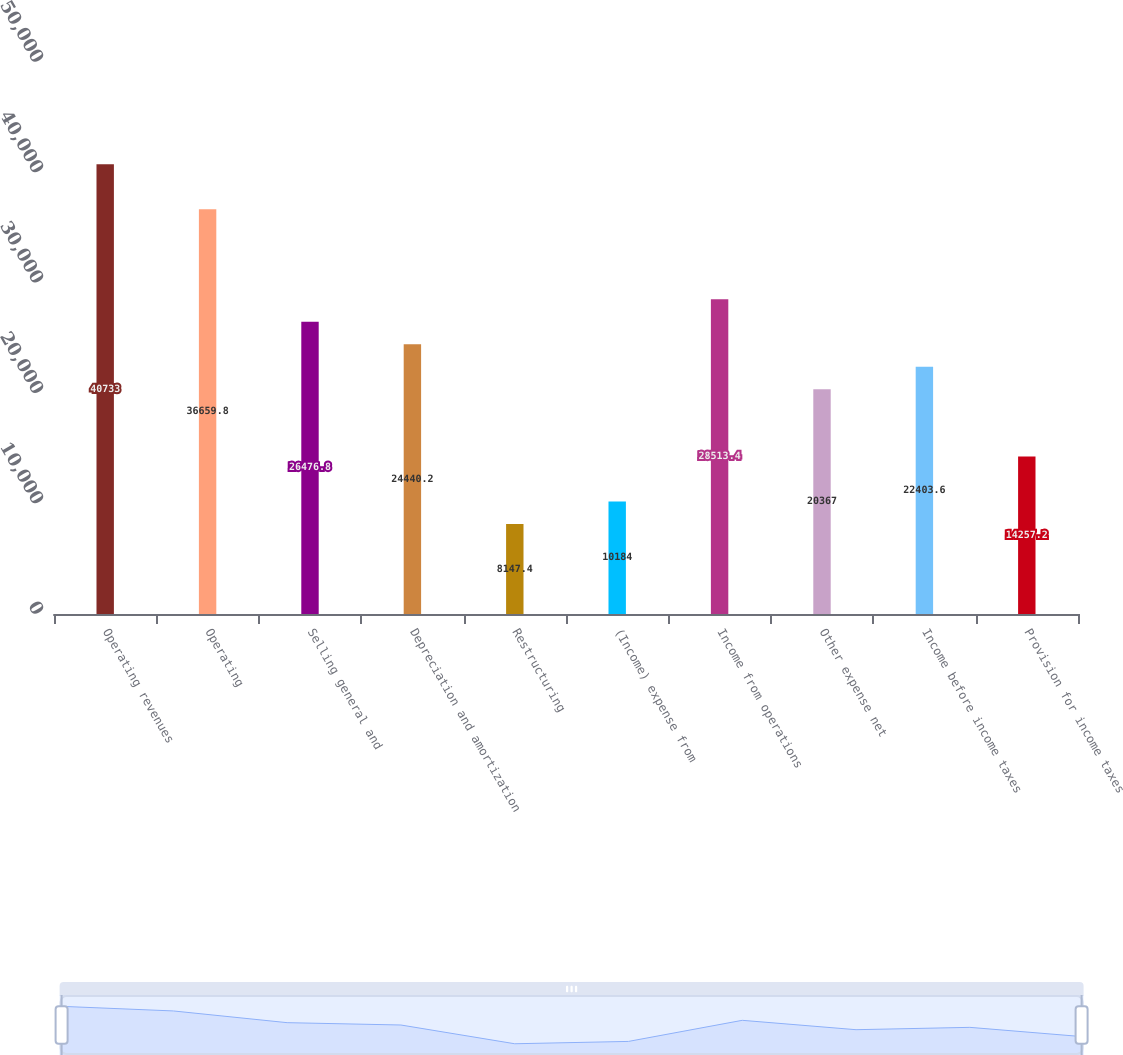<chart> <loc_0><loc_0><loc_500><loc_500><bar_chart><fcel>Operating revenues<fcel>Operating<fcel>Selling general and<fcel>Depreciation and amortization<fcel>Restructuring<fcel>(Income) expense from<fcel>Income from operations<fcel>Other expense net<fcel>Income before income taxes<fcel>Provision for income taxes<nl><fcel>40733<fcel>36659.8<fcel>26476.8<fcel>24440.2<fcel>8147.4<fcel>10184<fcel>28513.4<fcel>20367<fcel>22403.6<fcel>14257.2<nl></chart> 